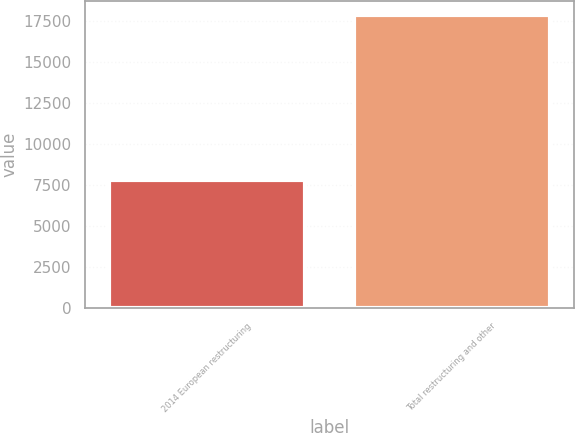Convert chart. <chart><loc_0><loc_0><loc_500><loc_500><bar_chart><fcel>2014 European restructuring<fcel>Total restructuring and other<nl><fcel>7808<fcel>17869<nl></chart> 